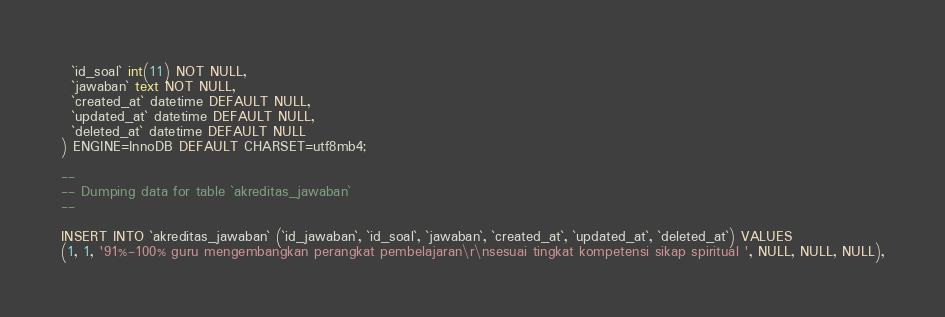<code> <loc_0><loc_0><loc_500><loc_500><_SQL_>  `id_soal` int(11) NOT NULL,
  `jawaban` text NOT NULL,
  `created_at` datetime DEFAULT NULL,
  `updated_at` datetime DEFAULT NULL,
  `deleted_at` datetime DEFAULT NULL
) ENGINE=InnoDB DEFAULT CHARSET=utf8mb4;

--
-- Dumping data for table `akreditas_jawaban`
--

INSERT INTO `akreditas_jawaban` (`id_jawaban`, `id_soal`, `jawaban`, `created_at`, `updated_at`, `deleted_at`) VALUES
(1, 1, '91%-100% guru mengembangkan perangkat pembelajaran\r\nsesuai tingkat kompetensi sikap spiritual ', NULL, NULL, NULL),</code> 